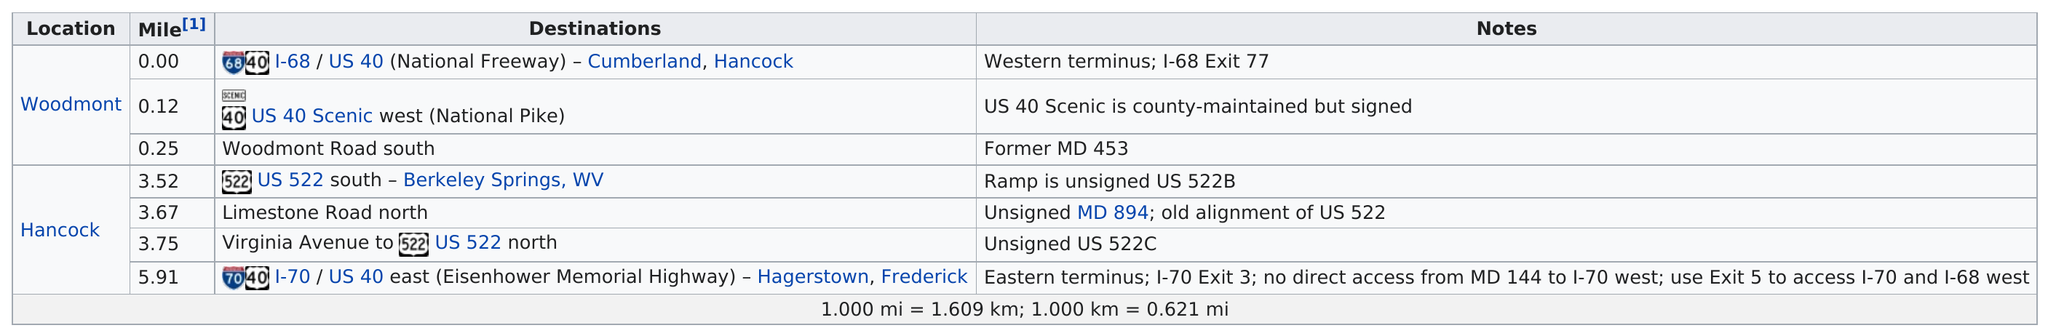Identify some key points in this picture. The total number of destinations in Woodmont is three. The exit before Virginia Avenue is Limestone Road North. The ramps located on US 522 south in Berkeley Springs, WV, Limestone Road north in Virginia, and US 522 north in Virginia, are not signed. The total number of destinations for the Hancock location is 4. The US 522 South - Berkeley Springs, WV location is 3.52 miles. 